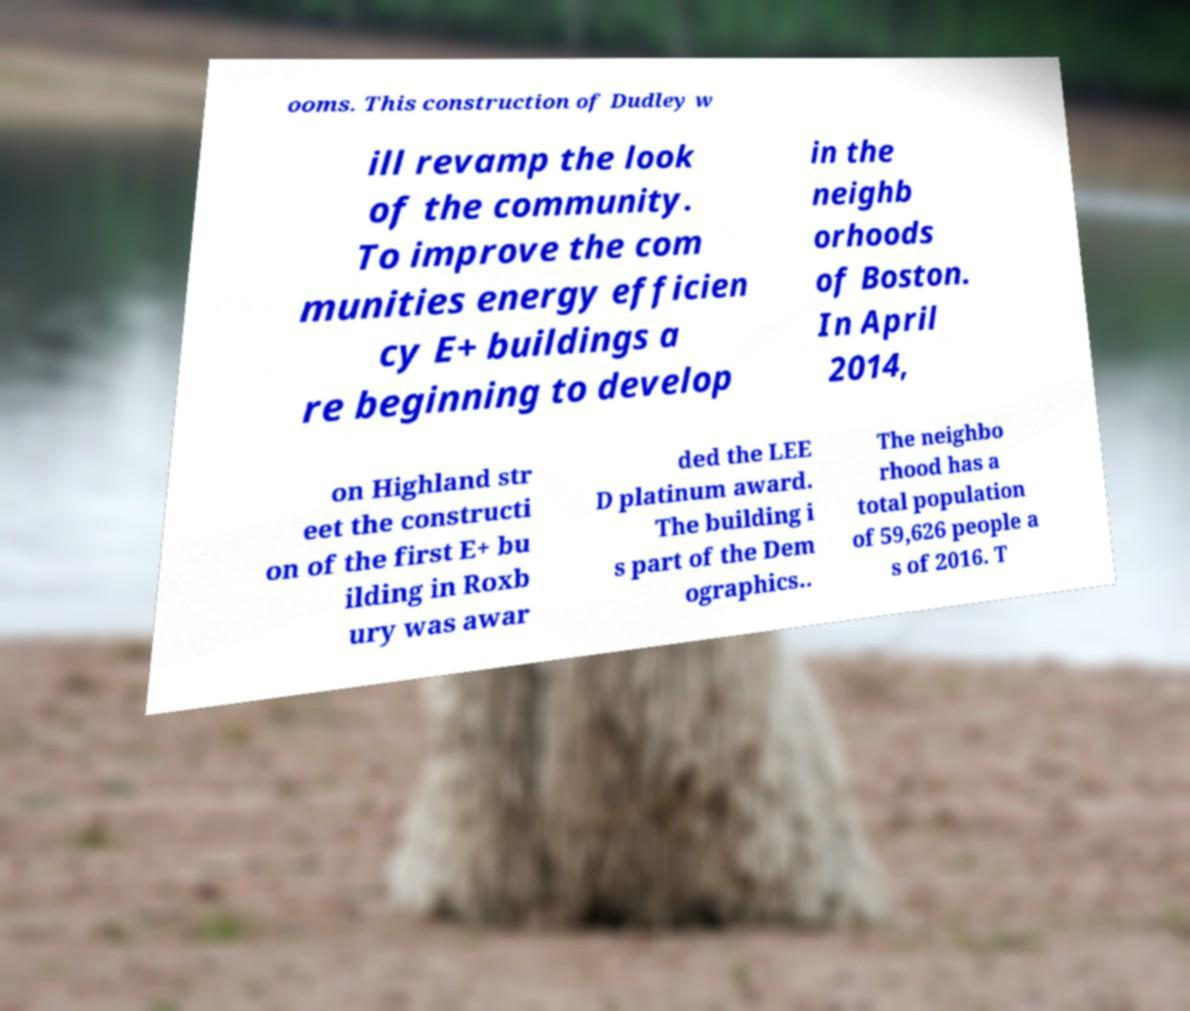Can you accurately transcribe the text from the provided image for me? ooms. This construction of Dudley w ill revamp the look of the community. To improve the com munities energy efficien cy E+ buildings a re beginning to develop in the neighb orhoods of Boston. In April 2014, on Highland str eet the constructi on of the first E+ bu ilding in Roxb ury was awar ded the LEE D platinum award. The building i s part of the Dem ographics.. The neighbo rhood has a total population of 59,626 people a s of 2016. T 